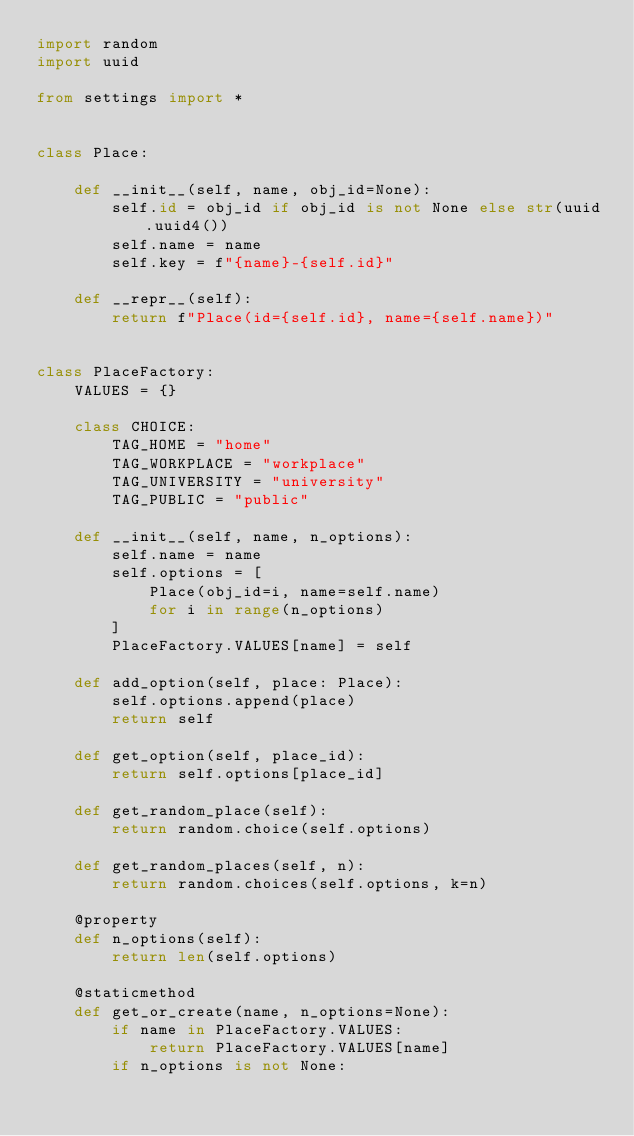<code> <loc_0><loc_0><loc_500><loc_500><_Python_>import random
import uuid

from settings import *


class Place:

    def __init__(self, name, obj_id=None):
        self.id = obj_id if obj_id is not None else str(uuid.uuid4())
        self.name = name
        self.key = f"{name}-{self.id}"

    def __repr__(self):
        return f"Place(id={self.id}, name={self.name})"


class PlaceFactory:
    VALUES = {}

    class CHOICE:
        TAG_HOME = "home"
        TAG_WORKPLACE = "workplace"
        TAG_UNIVERSITY = "university"
        TAG_PUBLIC = "public"

    def __init__(self, name, n_options):
        self.name = name
        self.options = [
            Place(obj_id=i, name=self.name)
            for i in range(n_options)
        ]
        PlaceFactory.VALUES[name] = self

    def add_option(self, place: Place):
        self.options.append(place)
        return self

    def get_option(self, place_id):
        return self.options[place_id]

    def get_random_place(self):
        return random.choice(self.options)

    def get_random_places(self, n):
        return random.choices(self.options, k=n)

    @property
    def n_options(self):
        return len(self.options)

    @staticmethod
    def get_or_create(name, n_options=None):
        if name in PlaceFactory.VALUES:
            return PlaceFactory.VALUES[name]
        if n_options is not None:</code> 